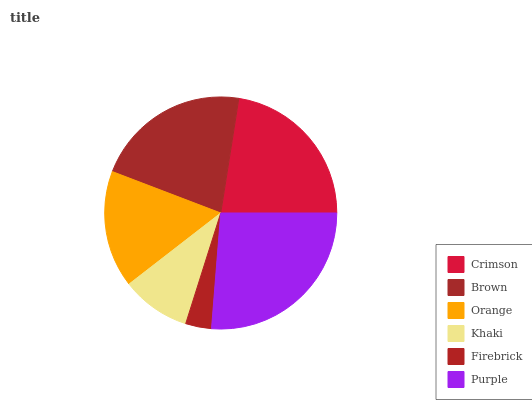Is Firebrick the minimum?
Answer yes or no. Yes. Is Purple the maximum?
Answer yes or no. Yes. Is Brown the minimum?
Answer yes or no. No. Is Brown the maximum?
Answer yes or no. No. Is Crimson greater than Brown?
Answer yes or no. Yes. Is Brown less than Crimson?
Answer yes or no. Yes. Is Brown greater than Crimson?
Answer yes or no. No. Is Crimson less than Brown?
Answer yes or no. No. Is Brown the high median?
Answer yes or no. Yes. Is Orange the low median?
Answer yes or no. Yes. Is Firebrick the high median?
Answer yes or no. No. Is Crimson the low median?
Answer yes or no. No. 